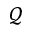Convert formula to latex. <formula><loc_0><loc_0><loc_500><loc_500>\mathcal { Q }</formula> 